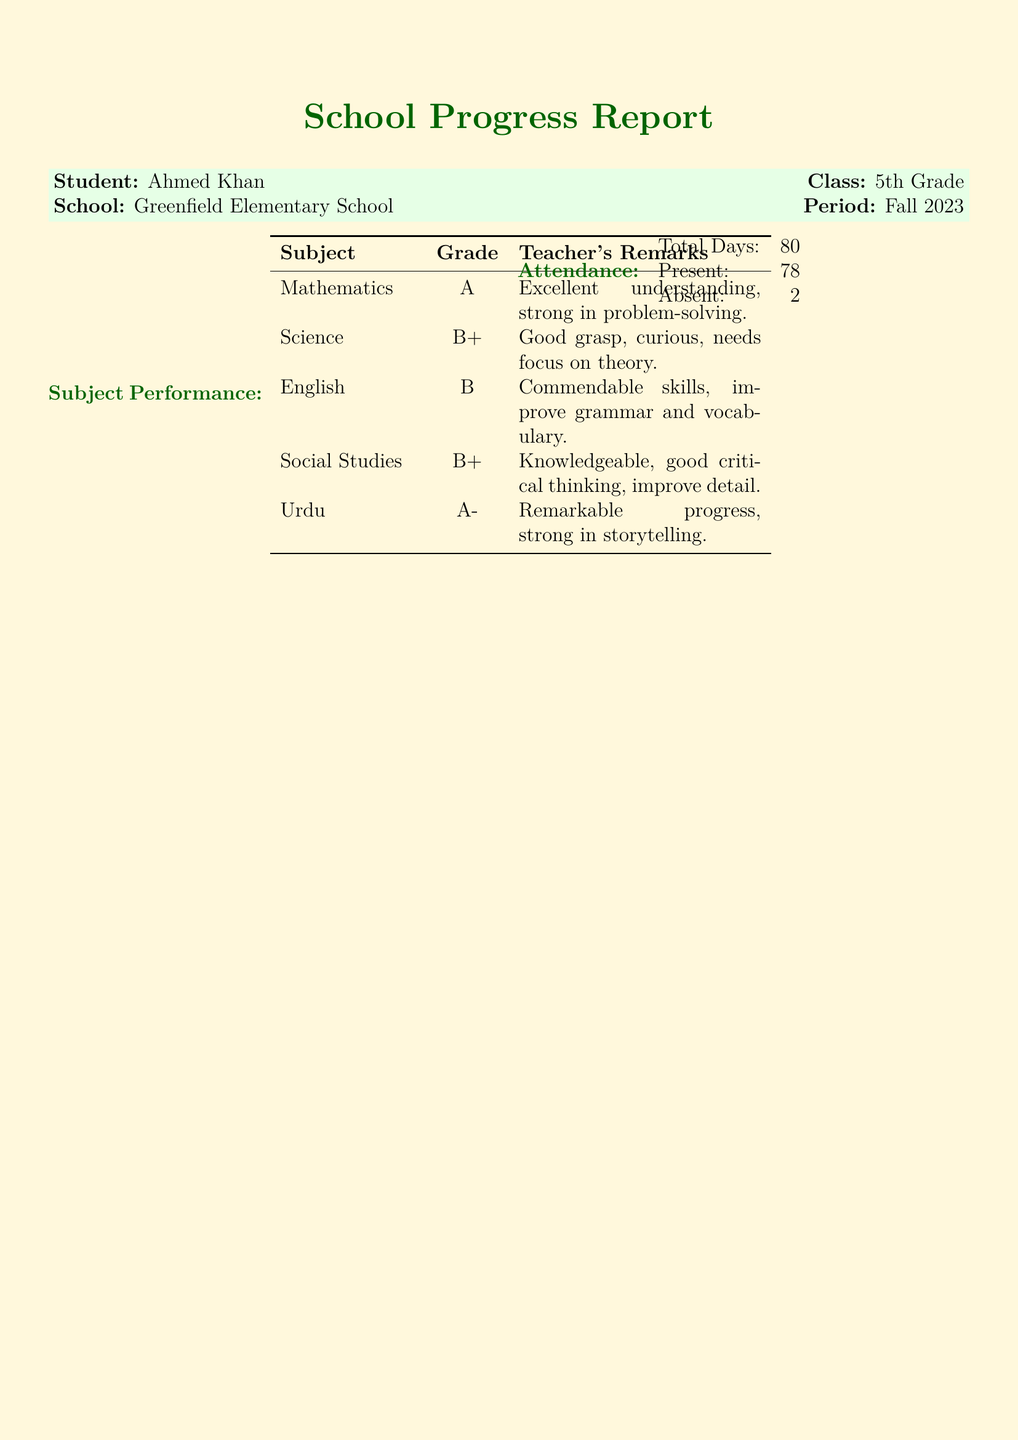What is the student's name? The student's name is provided in the progress report.
Answer: Ahmed Khan What subject received an A grade? The grades for each subject are listed, with specific grades assigned.
Answer: Mathematics How many days was Ahmed absent? The attendance section specifies the total days and the number of days absent.
Answer: 2 What is the teacher's name? The class teacher's name is mentioned at the end of the report.
Answer: Ms. Fatima Ali Which subject has the remark "needs focus on theory"? The remarks provide insights into each subject's performance and challenges.
Answer: Science What grade did Ahmed receive in Urdu? The document specifies the grades received in each subject.
Answer: A- What is Ahmed's total attendance? The total attendance days are mentioned in the attendance section.
Answer: 80 What are the recommendations provided for Ahmed? The recommendations are specified in a list format within the document.
Answer: Encourage more reading to enhance language skills What overall characteristic is highlighted about Ahmed? Overall comments provide insights into Ahmed's character and progress as a student.
Answer: Dedicated and responsible student 